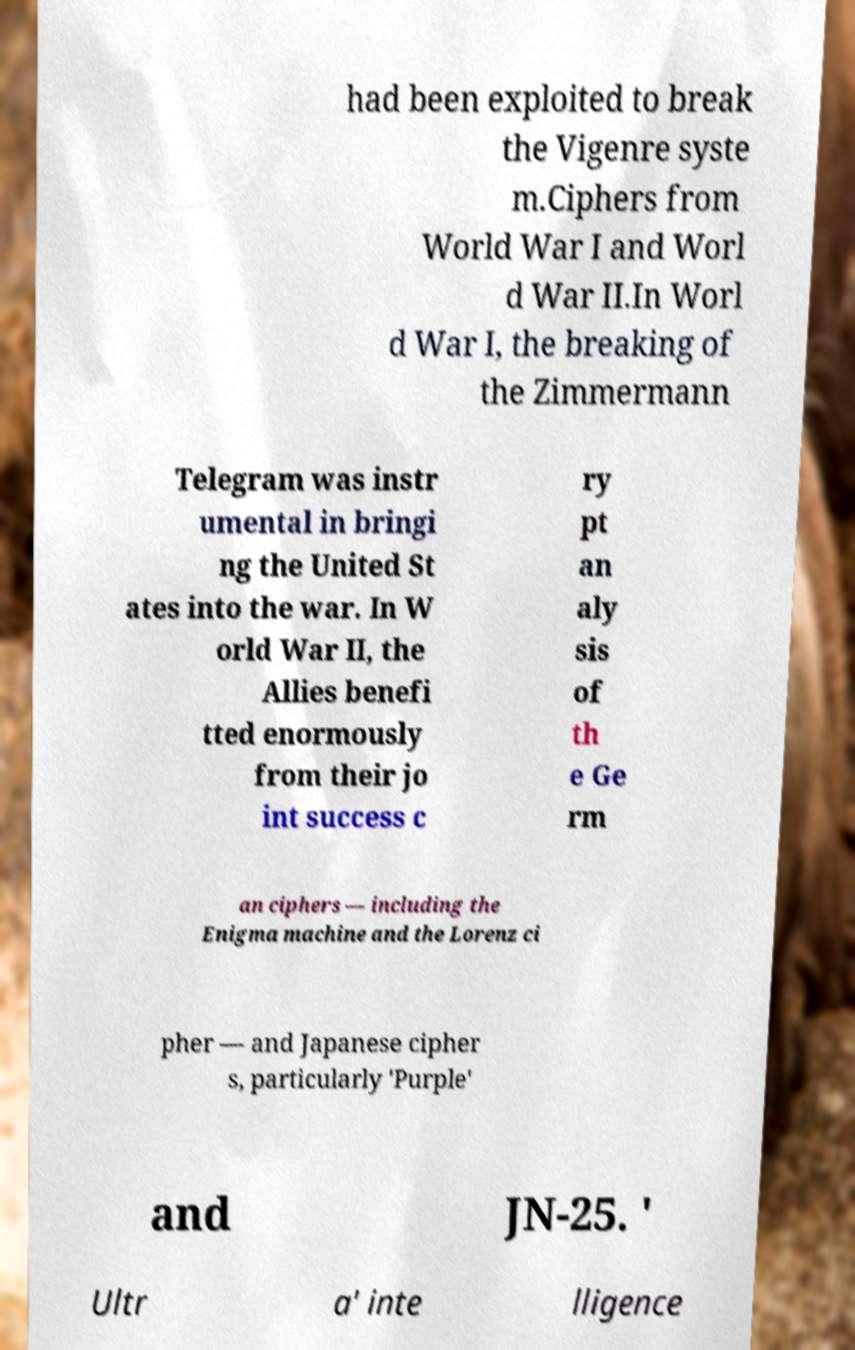What messages or text are displayed in this image? I need them in a readable, typed format. had been exploited to break the Vigenre syste m.Ciphers from World War I and Worl d War II.In Worl d War I, the breaking of the Zimmermann Telegram was instr umental in bringi ng the United St ates into the war. In W orld War II, the Allies benefi tted enormously from their jo int success c ry pt an aly sis of th e Ge rm an ciphers — including the Enigma machine and the Lorenz ci pher — and Japanese cipher s, particularly 'Purple' and JN-25. ' Ultr a' inte lligence 